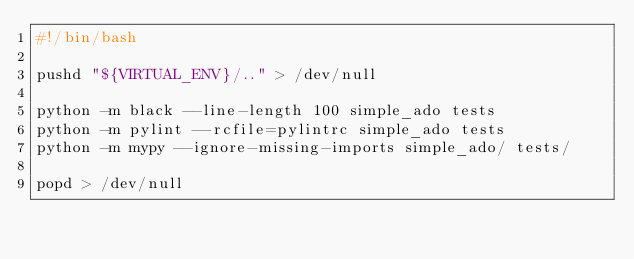<code> <loc_0><loc_0><loc_500><loc_500><_Bash_>#!/bin/bash

pushd "${VIRTUAL_ENV}/.." > /dev/null

python -m black --line-length 100 simple_ado tests
python -m pylint --rcfile=pylintrc simple_ado tests
python -m mypy --ignore-missing-imports simple_ado/ tests/

popd > /dev/null

</code> 